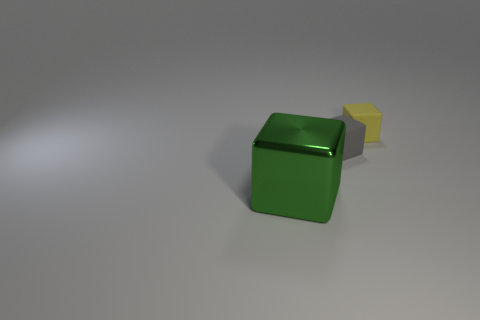There is a green metallic object that is the same shape as the small yellow thing; what is its size?
Offer a very short reply. Large. Is the number of large red metallic objects greater than the number of shiny objects?
Make the answer very short. No. Does the green metallic thing have the same shape as the small yellow thing?
Your answer should be compact. Yes. What is the cube that is left of the tiny matte block on the left side of the yellow block made of?
Give a very brief answer. Metal. Do the metal cube and the yellow block have the same size?
Make the answer very short. No. There is a tiny cube on the left side of the small yellow object; are there any gray things that are behind it?
Your answer should be compact. No. What shape is the matte object in front of the small yellow rubber cube?
Provide a short and direct response. Cube. What number of small rubber objects are on the left side of the cube on the left side of the matte object left of the tiny yellow rubber block?
Keep it short and to the point. 0. Is the size of the green metallic block the same as the matte block that is in front of the yellow matte block?
Offer a very short reply. No. What is the size of the rubber thing that is behind the matte cube that is left of the yellow block?
Keep it short and to the point. Small. 